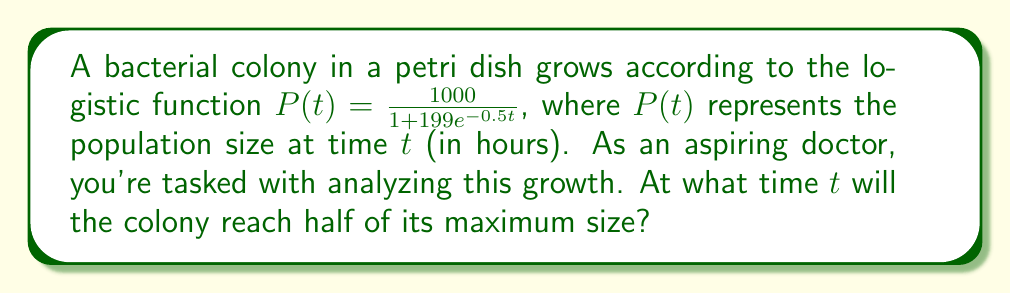Solve this math problem. Let's approach this step-by-step:

1) First, we need to identify the maximum population size. In a logistic function, this is the value that $P(t)$ approaches as $t$ goes to infinity. In this case, it's 1000.

2) We're looking for the time when the population is half of this maximum, so we're solving for $t$ when $P(t) = 500$.

3) Let's set up the equation:

   $$500 = \frac{1000}{1 + 199e^{-0.5t}}$$

4) Multiply both sides by $(1 + 199e^{-0.5t})$:

   $$500(1 + 199e^{-0.5t}) = 1000$$

5) Expand the left side:

   $$500 + 99500e^{-0.5t} = 1000$$

6) Subtract 500 from both sides:

   $$99500e^{-0.5t} = 500$$

7) Divide both sides by 99500:

   $$e^{-0.5t} = \frac{1}{199}$$

8) Take the natural log of both sides:

   $$-0.5t = \ln(\frac{1}{199}) = -\ln(199)$$

9) Divide both sides by -0.5:

   $$t = \frac{\ln(199)}{0.5} = 2\ln(199) \approx 10.58$$

Therefore, the colony will reach half its maximum size after approximately 10.58 hours.
Answer: $t = 2\ln(199) \approx 10.58$ hours 